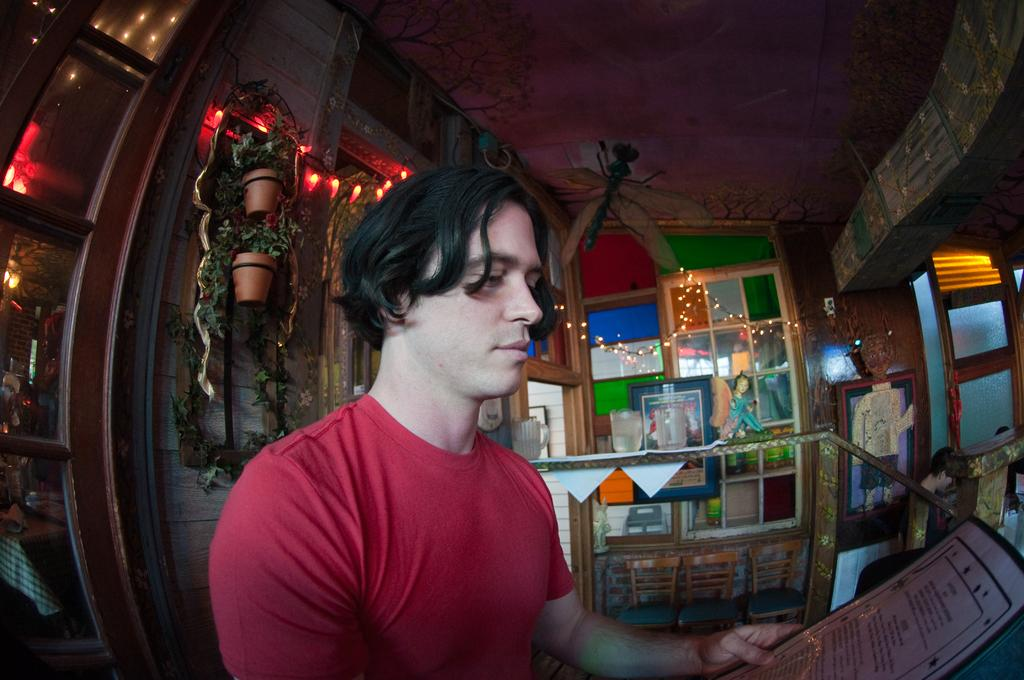What is the person in the image doing? The person is standing and holding an object in the image. What type of plants can be seen in the image? There are potted plants in the image. What might be used for watering the plants? Water cans are visible in the image. What type of furniture is present in the image? Chairs are present in the image. What type of lighting is present in the image? Decorative lights are in the image. What type of hydrant is visible in the image? There is no hydrant present in the image. What letters are written on the person's face in the image? There are no letters written on the person's face in the image. 